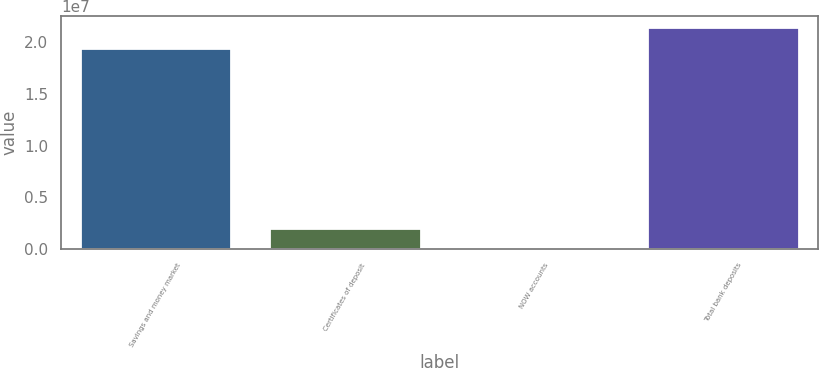<chart> <loc_0><loc_0><loc_500><loc_500><bar_chart><fcel>Savings and money market<fcel>Certificates of deposit<fcel>NOW accounts<fcel>Total bank deposits<nl><fcel>1.94745e+07<fcel>1.99939e+06<fcel>5823<fcel>2.14681e+07<nl></chart> 